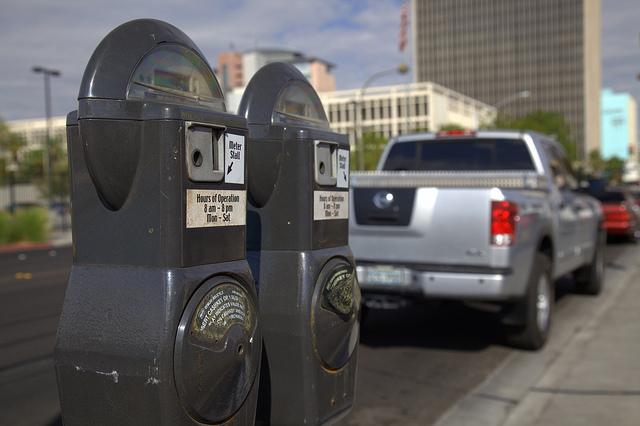Are there any palm trees?
Short answer required. No. Are the meters there to give out coins?
Be succinct. No. What kind of vehicle is parked near the meters?
Keep it brief. Truck. How does a person operate these devices?
Short answer required. Put in coins. What type of truck is in the background?
Keep it brief. Pick up. What color is the circle?
Concise answer only. Gray. What color are the meters?
Quick response, please. Gray. 